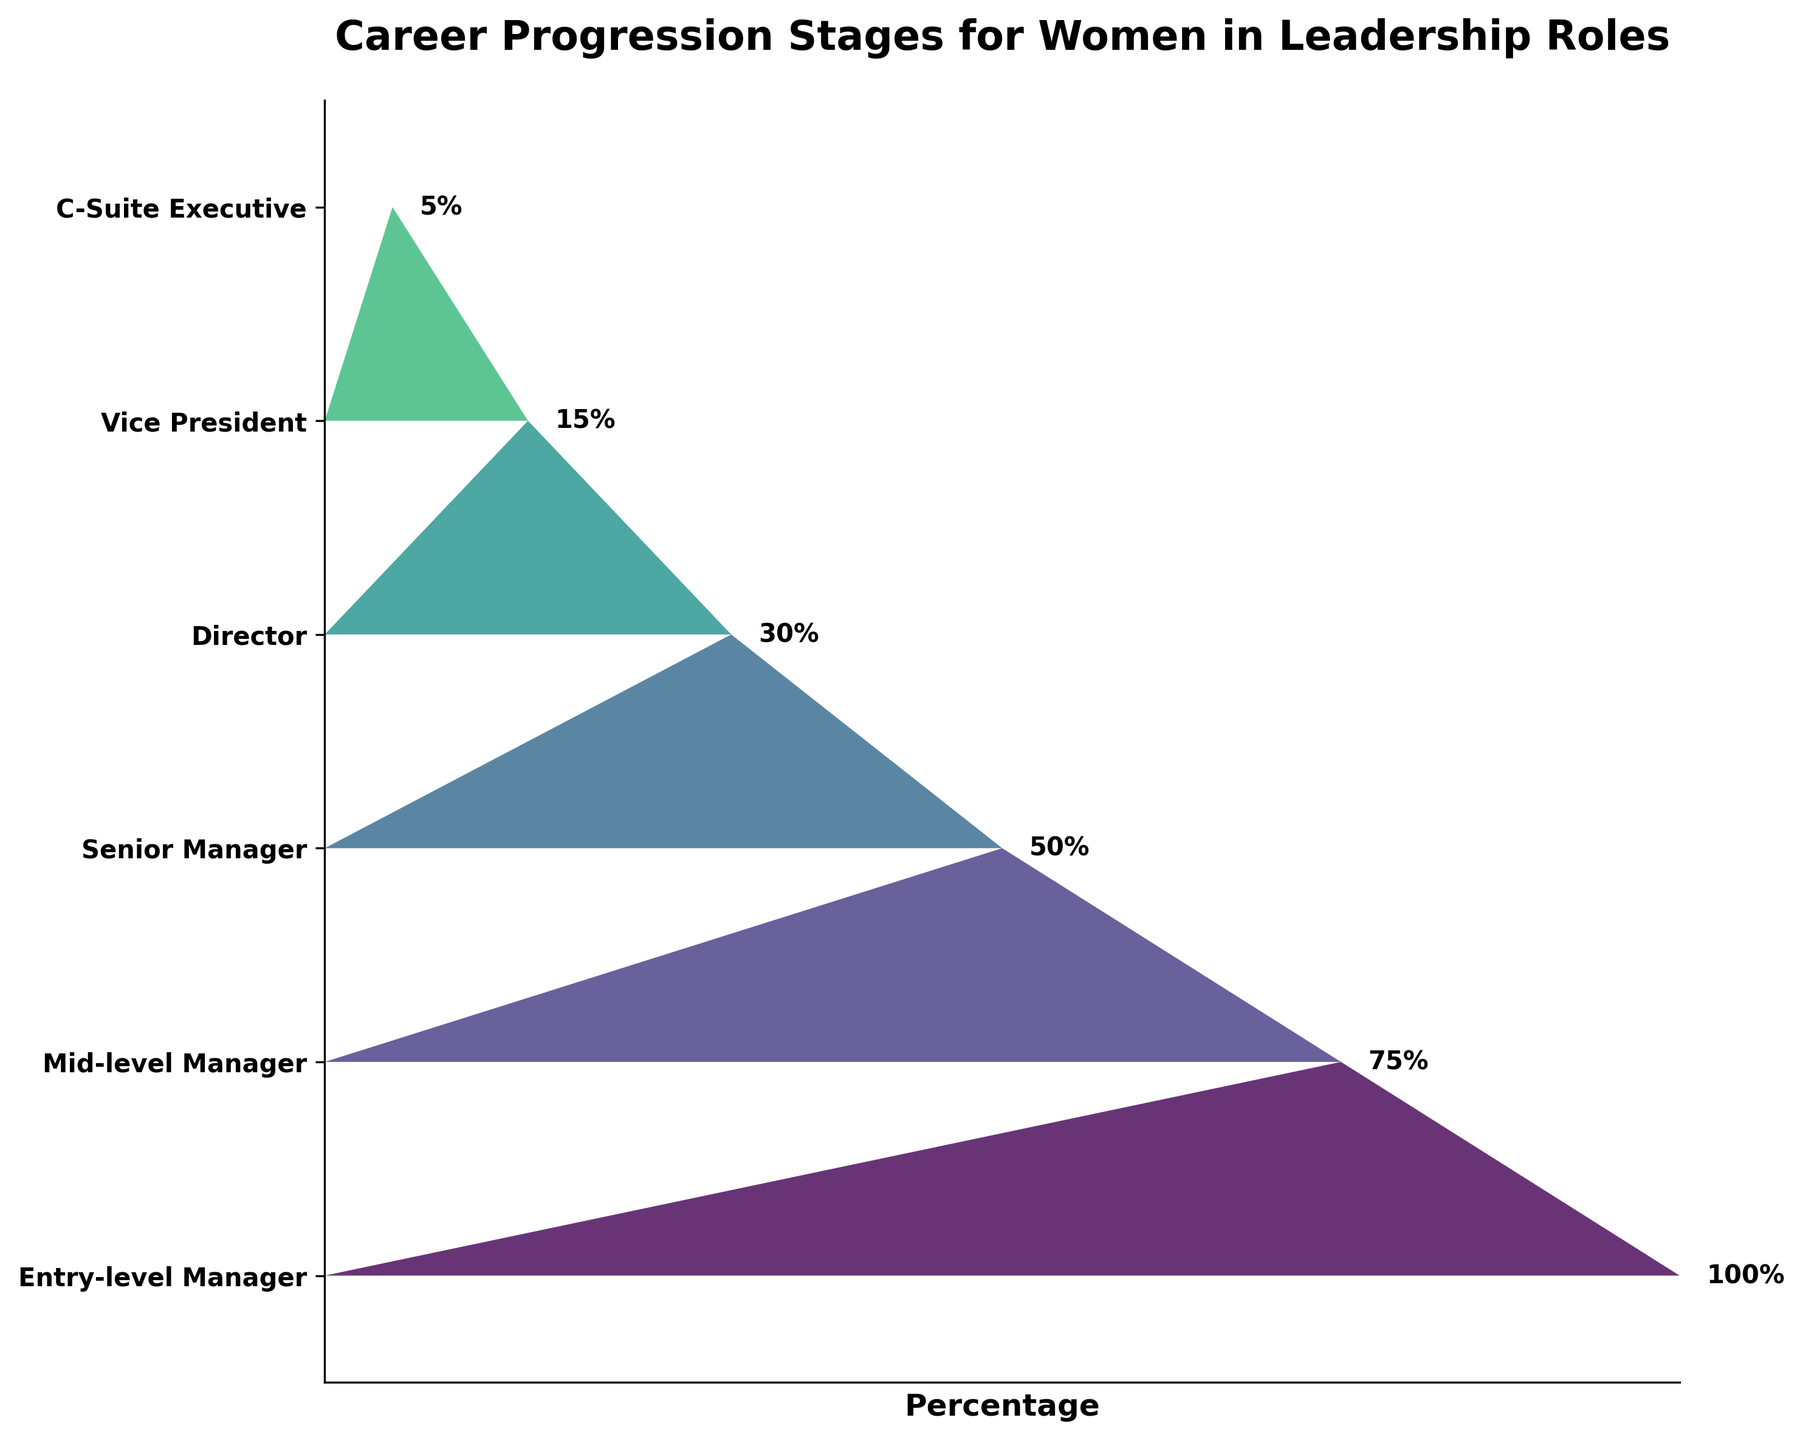How many stages are shown in the career progression figure? Count the number of distinct stages labeled on the y-axis.
Answer: 6 What percentage of women reach the mid-level manager stage? Locate the "Mid-level Manager" stage on the y-axis and find the corresponding percentage value.
Answer: 75% What is the difference in percentage between entry-level managers and senior managers? Subtract the percentage of senior managers from the percentage of entry-level managers (100% - 50%).
Answer: 50% Which stage has the smallest percentage representation? Identify the stage with the lowest percentage value on the plot.
Answer: C-Suite Executive How does the percentage of women decrease from director to vice president? Subtract the percentage of vice presidents from the percentage of directors (30% - 15%).
Answer: 15% What is the average percentage of women in leadership roles from entry-level manager to vice president? Add the percentages for each stage from entry-level manager to vice president and divide by the number of those stages (100 + 75 + 50 + 30 + 15)/5 = 54%.
Answer: 54% Which stage has a 20% higher representation than the vice president stage? Identify which stage has a percentage that is 20% more than the vice president stage (15% + 20% = 35%). No stage has exactly 35%, thus interpret next closest or approximate (Mid-level Manager at 75%).
Answer: Mid-level Manager What percentage of women does not progress beyond the director stage? Subtract the percentage of women at the director stage from the entry-level manager percentage (100% - 30%).
Answer: 70% Compare the percentage representation between senior managers and C-suite executives. Find the difference between the percentages for senior managers and C-suite executives (50% - 5%).
Answer: 45% What trend is observed in the percentage representation of women as they progress from entry-level to higher leadership roles? The percentage of women decreases consistently at each subsequent stage from entry-level to C-Suite Executive.
Answer: Decreasing trend 